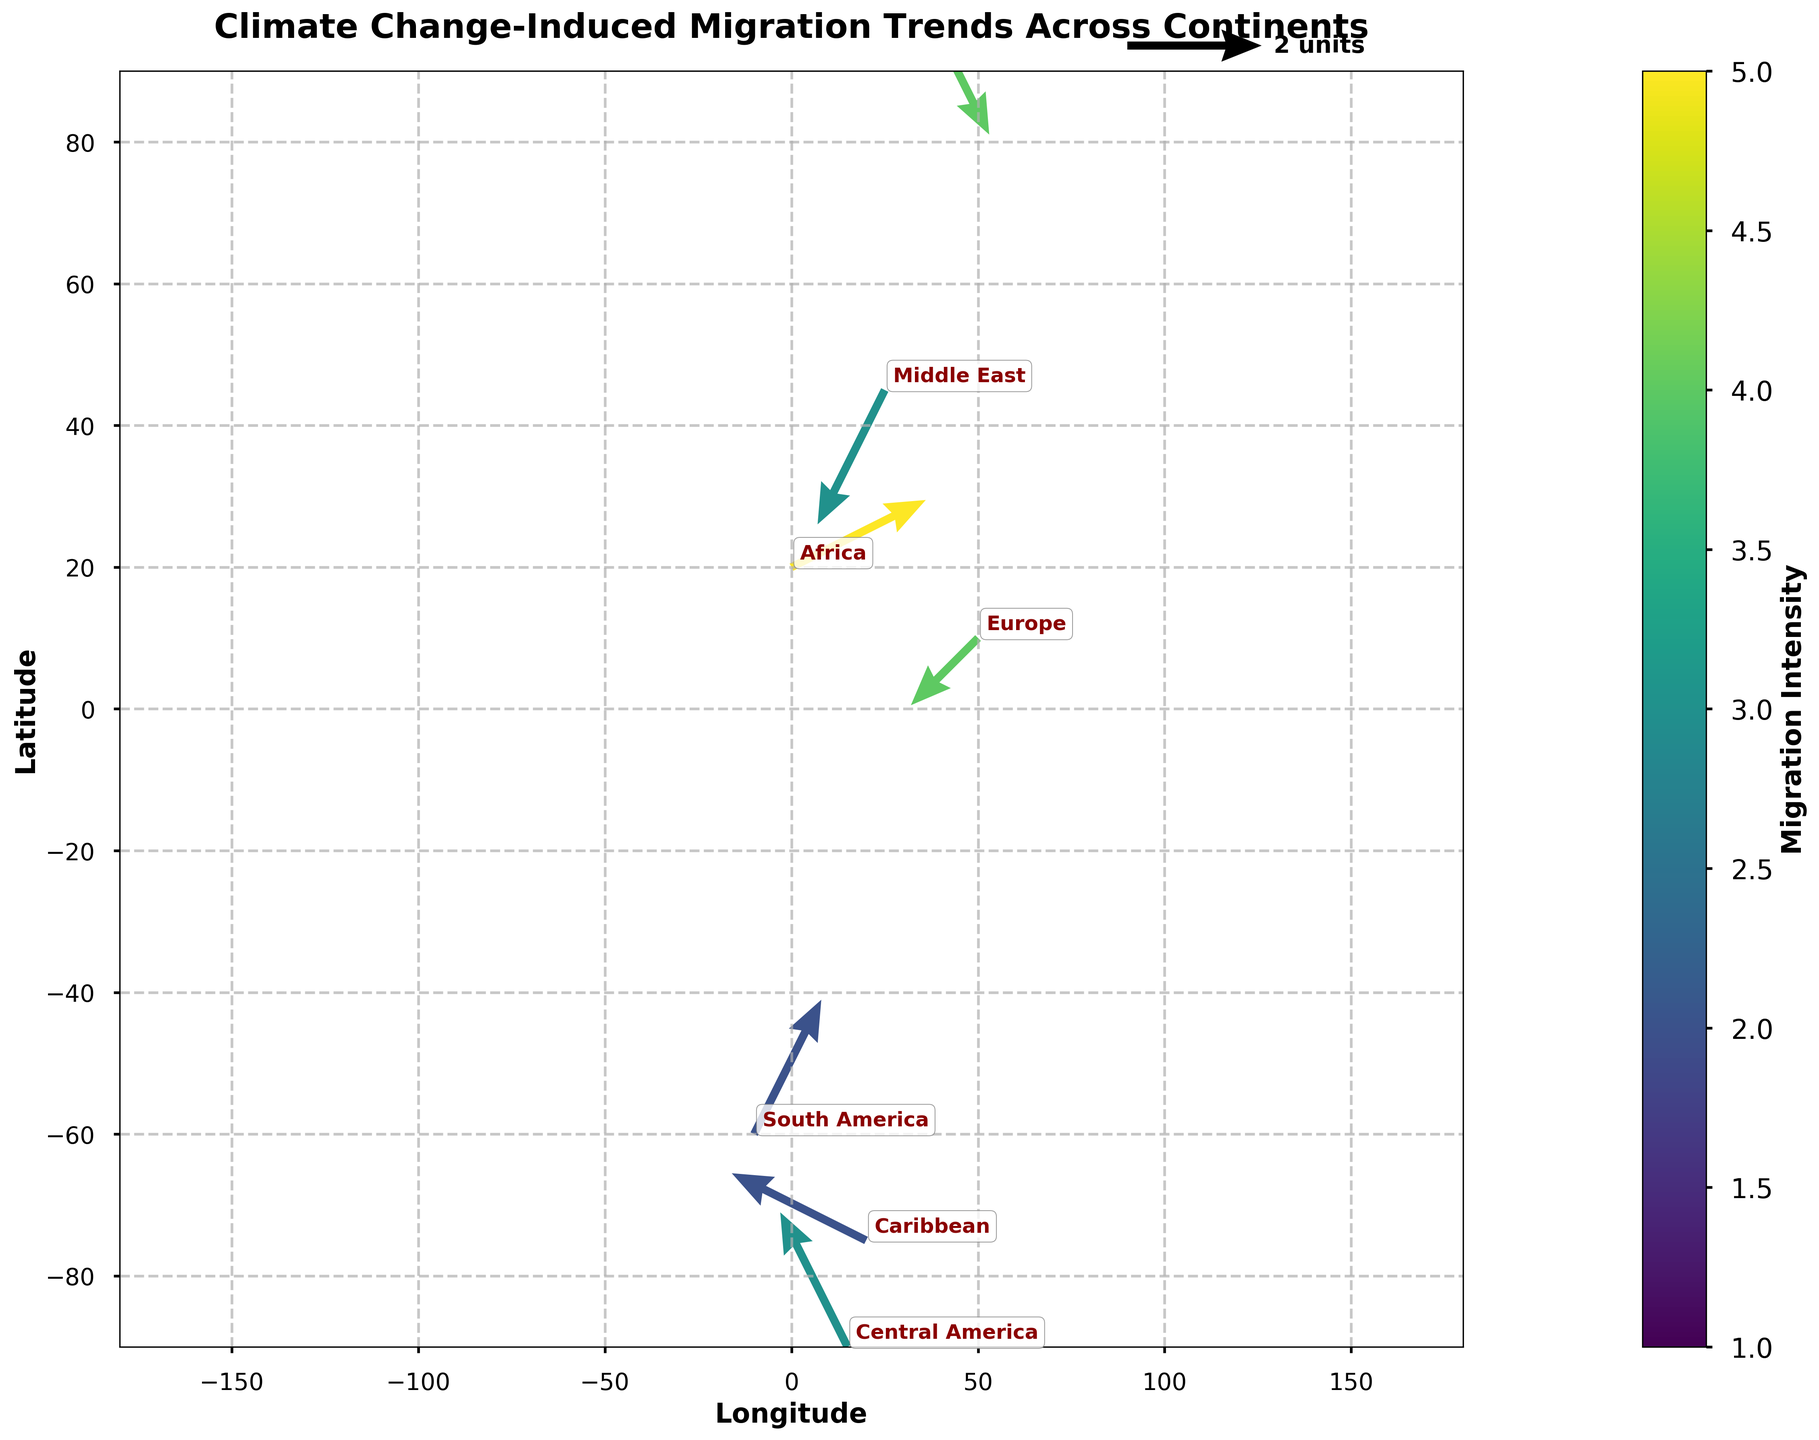What is the title of the figure? The title is displayed prominently at the top of the figure. It reads "Climate Change-Induced Migration Trends Across Continents".
Answer: Climate Change-Induced Migration Trends Across Continents In which direction is the migration trend for North America? The arrow originating from North America points towards the southwest. This indicates that the migration trend is directed towards the southwest direction.
Answer: Southwest Which continent has the highest intensity of migration? The intensity of migration is represented by the color of the arrows. Africa has the darkest shade, representing the highest intensity.
Answer: Africa How many continents have a migration trend towards the northeast? By observing the direction of the arrows, South America and Central America have trends pointing towards the northeast.
Answer: 2 What is the migration trend for Europe in terms of direction and intensity? The arrow from Europe points towards the southwest direction and has a moderate color indicating an intensity level of 4.
Answer: Southwest, 4 Compare the migration trends of Asia and Southeast Asia. The arrow from Asia points towards the southwest with an intensity of 4, whereas the arrow from Southeast Asia points towards the west-northwest with an intensity of 2.
Answer: Asia: Southwest, 4; Southeast Asia: West-northwest, 2 Which continent shows the weakest migration intensity, and what direction is it trending? The lightest colored arrow is from Australia, indicating the weakest intensity of 1, and it points towards the north.
Answer: Australia, north What is the migration intensity for the Middle East, and which direction is it trending? The arrow from the Middle East points towards the southwest with a moderate color indicating an intensity level of 3.
Answer: Southwest, 3 Is there any continent with a migration trend toward the northwest? Observing the arrows, it’s clear that none of the arrows are trending towards the northwest direction.
Answer: No How does the migration trend for North America compare to the Caribbean? Both North America and the Caribbean have arrows pointing towards the southwest, but North America's trend has an intensity of 3, whereas the Caribbean's intensity is 2.
Answer: North America: Southwest, intensity 3; Caribbean: Southwest, intensity 2 